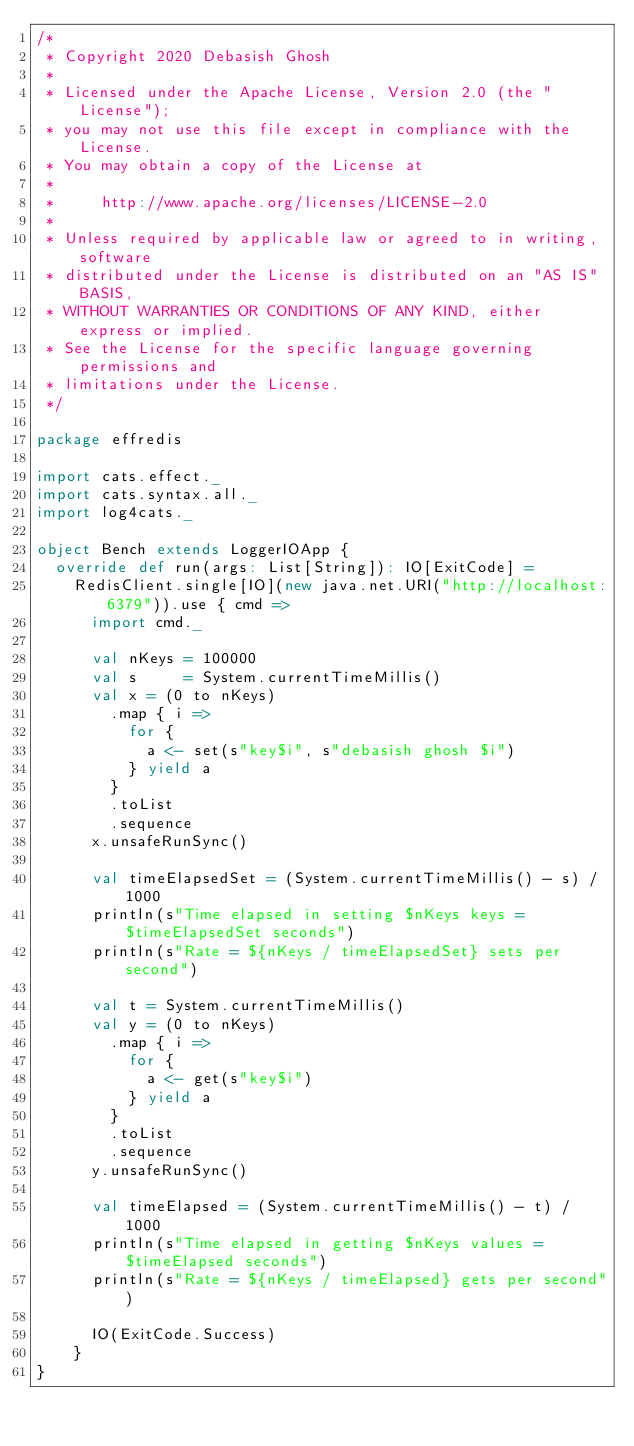Convert code to text. <code><loc_0><loc_0><loc_500><loc_500><_Scala_>/*
 * Copyright 2020 Debasish Ghosh
 *
 * Licensed under the Apache License, Version 2.0 (the "License");
 * you may not use this file except in compliance with the License.
 * You may obtain a copy of the License at
 *
 *     http://www.apache.org/licenses/LICENSE-2.0
 *
 * Unless required by applicable law or agreed to in writing, software
 * distributed under the License is distributed on an "AS IS" BASIS,
 * WITHOUT WARRANTIES OR CONDITIONS OF ANY KIND, either express or implied.
 * See the License for the specific language governing permissions and
 * limitations under the License.
 */

package effredis

import cats.effect._
import cats.syntax.all._
import log4cats._

object Bench extends LoggerIOApp {
  override def run(args: List[String]): IO[ExitCode] =
    RedisClient.single[IO](new java.net.URI("http://localhost:6379")).use { cmd =>
      import cmd._

      val nKeys = 100000
      val s     = System.currentTimeMillis()
      val x = (0 to nKeys)
        .map { i =>
          for {
            a <- set(s"key$i", s"debasish ghosh $i")
          } yield a
        }
        .toList
        .sequence
      x.unsafeRunSync()

      val timeElapsedSet = (System.currentTimeMillis() - s) / 1000
      println(s"Time elapsed in setting $nKeys keys = $timeElapsedSet seconds")
      println(s"Rate = ${nKeys / timeElapsedSet} sets per second")

      val t = System.currentTimeMillis()
      val y = (0 to nKeys)
        .map { i =>
          for {
            a <- get(s"key$i")
          } yield a
        }
        .toList
        .sequence
      y.unsafeRunSync()

      val timeElapsed = (System.currentTimeMillis() - t) / 1000
      println(s"Time elapsed in getting $nKeys values = $timeElapsed seconds")
      println(s"Rate = ${nKeys / timeElapsed} gets per second")

      IO(ExitCode.Success)
    }
}
</code> 